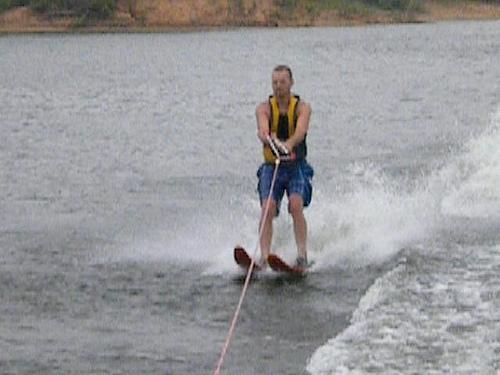How many people are wearing white shirt near the sea ?
Give a very brief answer. 0. 